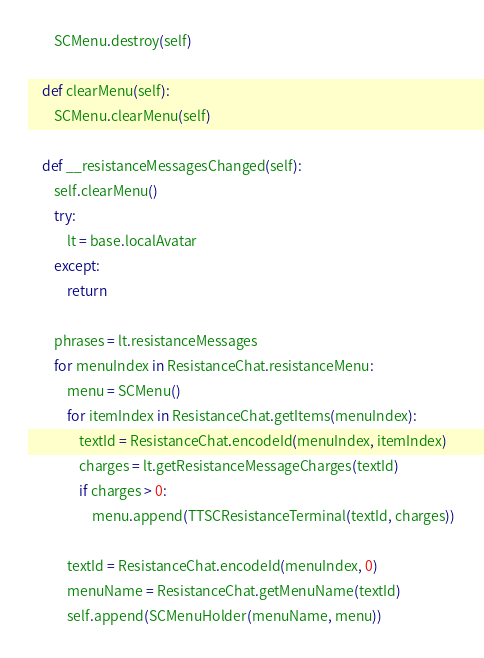Convert code to text. <code><loc_0><loc_0><loc_500><loc_500><_Python_>        SCMenu.destroy(self)

    def clearMenu(self):
        SCMenu.clearMenu(self)

    def __resistanceMessagesChanged(self):
        self.clearMenu()
        try:
            lt = base.localAvatar
        except:
            return

        phrases = lt.resistanceMessages
        for menuIndex in ResistanceChat.resistanceMenu:
            menu = SCMenu()
            for itemIndex in ResistanceChat.getItems(menuIndex):
                textId = ResistanceChat.encodeId(menuIndex, itemIndex)
                charges = lt.getResistanceMessageCharges(textId)
                if charges > 0:
                    menu.append(TTSCResistanceTerminal(textId, charges))

            textId = ResistanceChat.encodeId(menuIndex, 0)
            menuName = ResistanceChat.getMenuName(textId)
            self.append(SCMenuHolder(menuName, menu))
</code> 